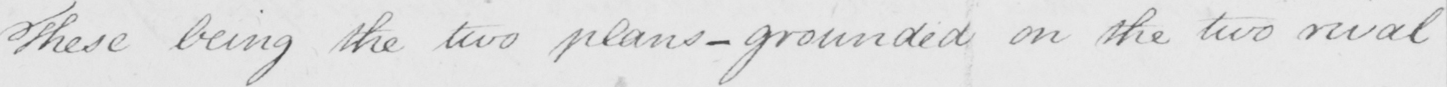Please provide the text content of this handwritten line. These being the two plans _ grounded on the two rival 